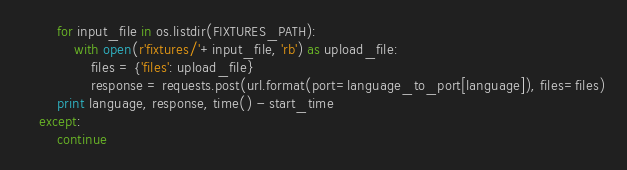Convert code to text. <code><loc_0><loc_0><loc_500><loc_500><_Python_>        for input_file in os.listdir(FIXTURES_PATH):
            with open(r'fixtures/'+input_file, 'rb') as upload_file:
                files = {'files': upload_file}
                response = requests.post(url.format(port=language_to_port[language]), files=files)
        print language, response, time() - start_time
    except:
        continue
</code> 